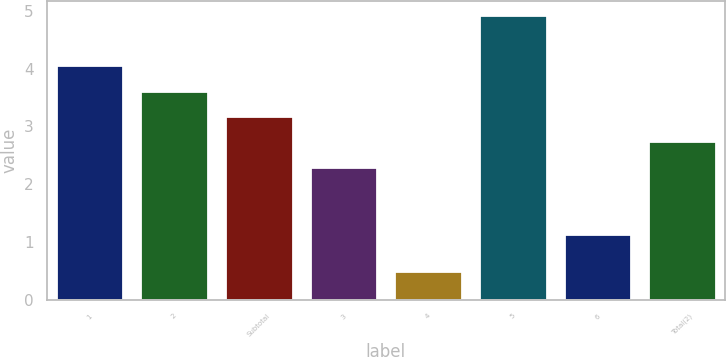Convert chart to OTSL. <chart><loc_0><loc_0><loc_500><loc_500><bar_chart><fcel>1<fcel>2<fcel>Subtotal<fcel>3<fcel>4<fcel>5<fcel>6<fcel>Total(2)<nl><fcel>4.06<fcel>3.62<fcel>3.18<fcel>2.3<fcel>0.5<fcel>4.92<fcel>1.13<fcel>2.74<nl></chart> 